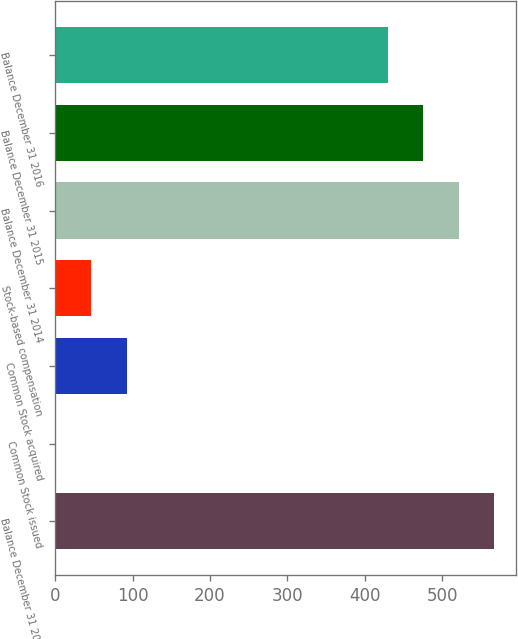<chart> <loc_0><loc_0><loc_500><loc_500><bar_chart><fcel>Balance December 31 2013<fcel>Common Stock issued<fcel>Common Stock acquired<fcel>Stock-based compensation<fcel>Balance December 31 2014<fcel>Balance December 31 2015<fcel>Balance December 31 2016<nl><fcel>567.84<fcel>0.34<fcel>92.5<fcel>46.42<fcel>521.76<fcel>475.68<fcel>429.6<nl></chart> 